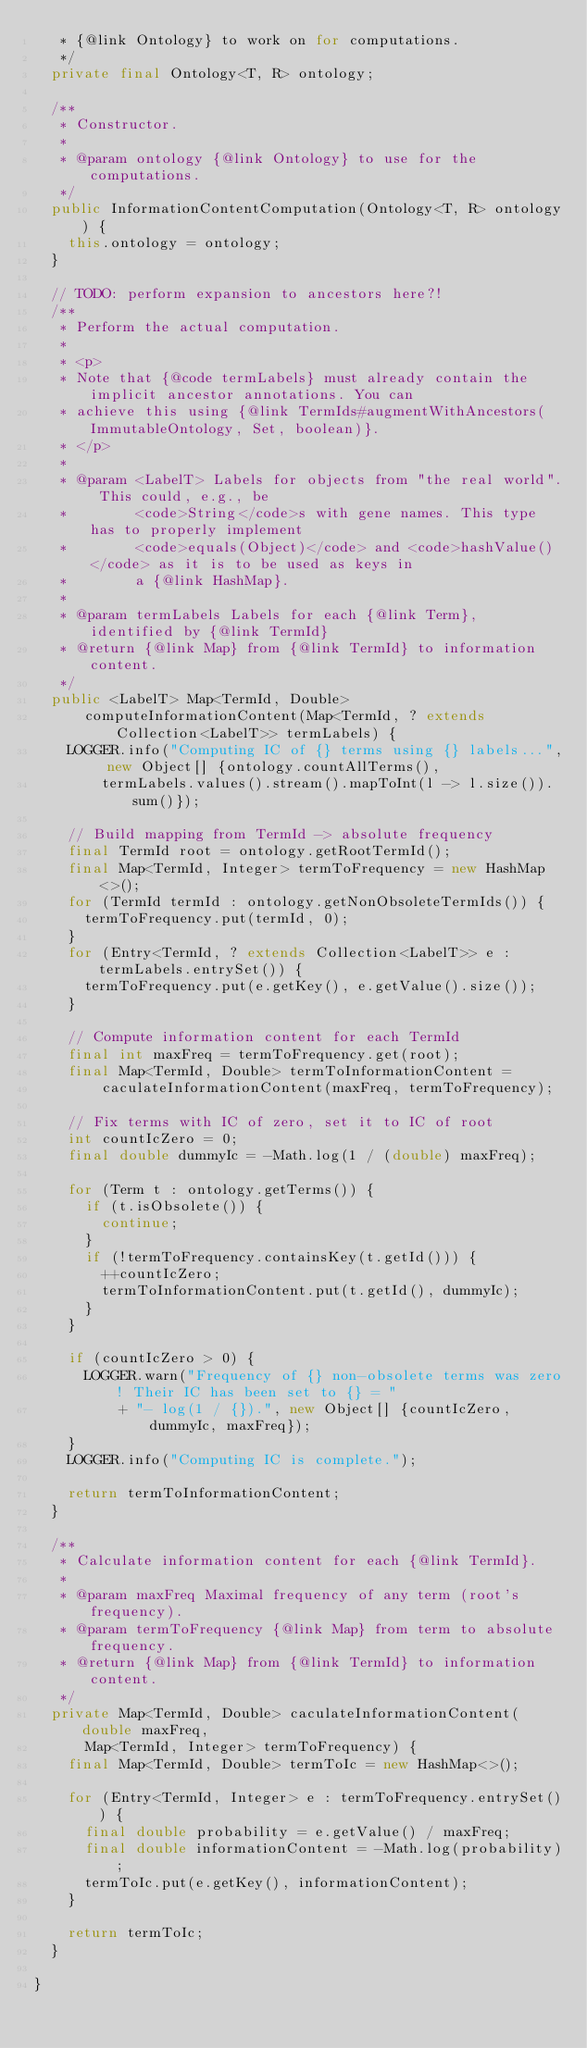<code> <loc_0><loc_0><loc_500><loc_500><_Java_>   * {@link Ontology} to work on for computations.
   */
  private final Ontology<T, R> ontology;

  /**
   * Constructor.
   *
   * @param ontology {@link Ontology} to use for the computations.
   */
  public InformationContentComputation(Ontology<T, R> ontology) {
    this.ontology = ontology;
  }

  // TODO: perform expansion to ancestors here?!
  /**
   * Perform the actual computation.
   *
   * <p>
   * Note that {@code termLabels} must already contain the implicit ancestor annotations. You can
   * achieve this using {@link TermIds#augmentWithAncestors(ImmutableOntology, Set, boolean)}.
   * </p>
   *
   * @param <LabelT> Labels for objects from "the real world". This could, e.g., be
   *        <code>String</code>s with gene names. This type has to properly implement
   *        <code>equals(Object)</code> and <code>hashValue()</code> as it is to be used as keys in
   *        a {@link HashMap}.
   *
   * @param termLabels Labels for each {@link Term}, identified by {@link TermId}
   * @return {@link Map} from {@link TermId} to information content.
   */
  public <LabelT> Map<TermId, Double>
      computeInformationContent(Map<TermId, ? extends Collection<LabelT>> termLabels) {
    LOGGER.info("Computing IC of {} terms using {} labels...", new Object[] {ontology.countAllTerms(),
        termLabels.values().stream().mapToInt(l -> l.size()).sum()});

    // Build mapping from TermId -> absolute frequency
    final TermId root = ontology.getRootTermId();
    final Map<TermId, Integer> termToFrequency = new HashMap<>();
    for (TermId termId : ontology.getNonObsoleteTermIds()) {
      termToFrequency.put(termId, 0);
    }
    for (Entry<TermId, ? extends Collection<LabelT>> e : termLabels.entrySet()) {
      termToFrequency.put(e.getKey(), e.getValue().size());
    }

    // Compute information content for each TermId
    final int maxFreq = termToFrequency.get(root);
    final Map<TermId, Double> termToInformationContent =
        caculateInformationContent(maxFreq, termToFrequency);

    // Fix terms with IC of zero, set it to IC of root
    int countIcZero = 0;
    final double dummyIc = -Math.log(1 / (double) maxFreq);

    for (Term t : ontology.getTerms()) {
      if (t.isObsolete()) {
        continue;
      }
      if (!termToFrequency.containsKey(t.getId())) {
        ++countIcZero;
        termToInformationContent.put(t.getId(), dummyIc);
      }
    }

    if (countIcZero > 0) {
      LOGGER.warn("Frequency of {} non-obsolete terms was zero! Their IC has been set to {} = "
          + "- log(1 / {}).", new Object[] {countIcZero, dummyIc, maxFreq});
    }
    LOGGER.info("Computing IC is complete.");

    return termToInformationContent;
  }

  /**
   * Calculate information content for each {@link TermId}.
   *
   * @param maxFreq Maximal frequency of any term (root's frequency).
   * @param termToFrequency {@link Map} from term to absolute frequency.
   * @return {@link Map} from {@link TermId} to information content.
   */
  private Map<TermId, Double> caculateInformationContent(double maxFreq,
      Map<TermId, Integer> termToFrequency) {
    final Map<TermId, Double> termToIc = new HashMap<>();

    for (Entry<TermId, Integer> e : termToFrequency.entrySet()) {
      final double probability = e.getValue() / maxFreq;
      final double informationContent = -Math.log(probability);
      termToIc.put(e.getKey(), informationContent);
    }

    return termToIc;
  }

}
</code> 